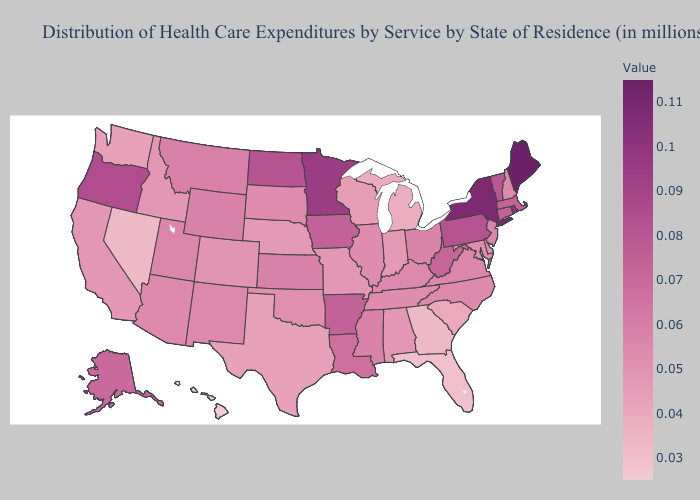Among the states that border Tennessee , which have the lowest value?
Quick response, please. Georgia. Does Alabama have the lowest value in the USA?
Keep it brief. No. Does North Dakota have a lower value than Rhode Island?
Write a very short answer. Yes. Does Connecticut have the highest value in the Northeast?
Short answer required. No. Which states have the lowest value in the USA?
Write a very short answer. Hawaii. Among the states that border Arizona , which have the lowest value?
Be succinct. Nevada. 